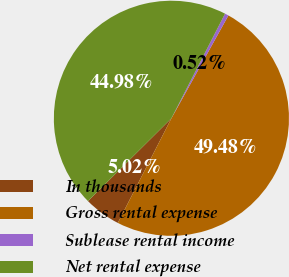Convert chart. <chart><loc_0><loc_0><loc_500><loc_500><pie_chart><fcel>In thousands<fcel>Gross rental expense<fcel>Sublease rental income<fcel>Net rental expense<nl><fcel>5.02%<fcel>49.48%<fcel>0.52%<fcel>44.98%<nl></chart> 